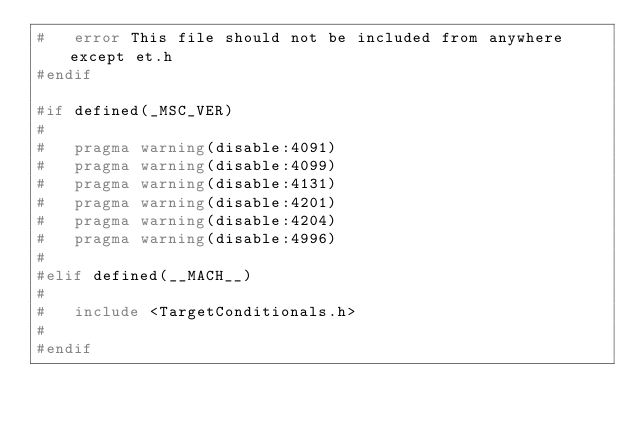Convert code to text. <code><loc_0><loc_0><loc_500><loc_500><_C_>#	error This file should not be included from anywhere except et.h
#endif

#if defined(_MSC_VER)
#
#	pragma warning(disable:4091)
#	pragma warning(disable:4099)
#	pragma warning(disable:4131)
#	pragma warning(disable:4201)
#	pragma warning(disable:4204)
#	pragma warning(disable:4996)
#
#elif defined(__MACH__)
#
#	include <TargetConditionals.h>
#
#endif
</code> 